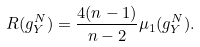<formula> <loc_0><loc_0><loc_500><loc_500>R ( g ^ { N } _ { Y } ) = \frac { 4 ( n - 1 ) } { n - 2 } \mu _ { 1 } ( g ^ { N } _ { Y } ) .</formula> 